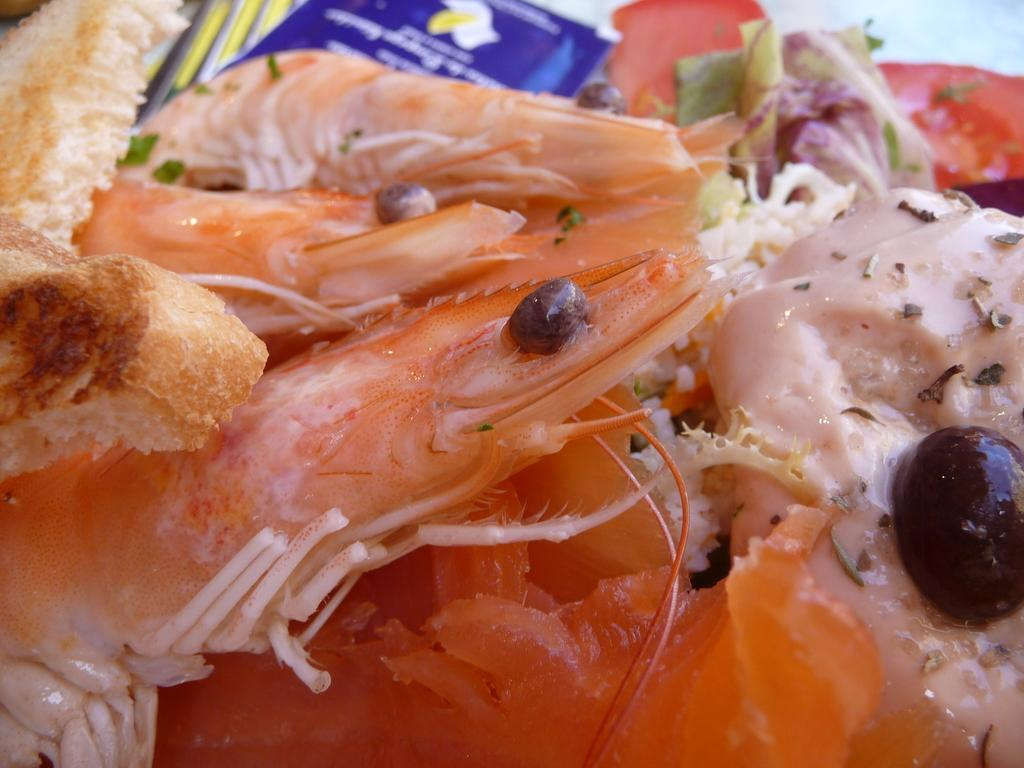What is the main subject in the foreground of the image? There are prawns in the foreground of the image. Are there any other items visible in the foreground besides the prawns? Yes, there are other items in the foreground of the image. What type of quilt is being used as a chessboard in the image? There is no quilt or chessboard present in the image; it features prawns and other items in the foreground. What kind of ornament is hanging from the prawns in the image? There are no ornaments hanging from the prawns in the image. 